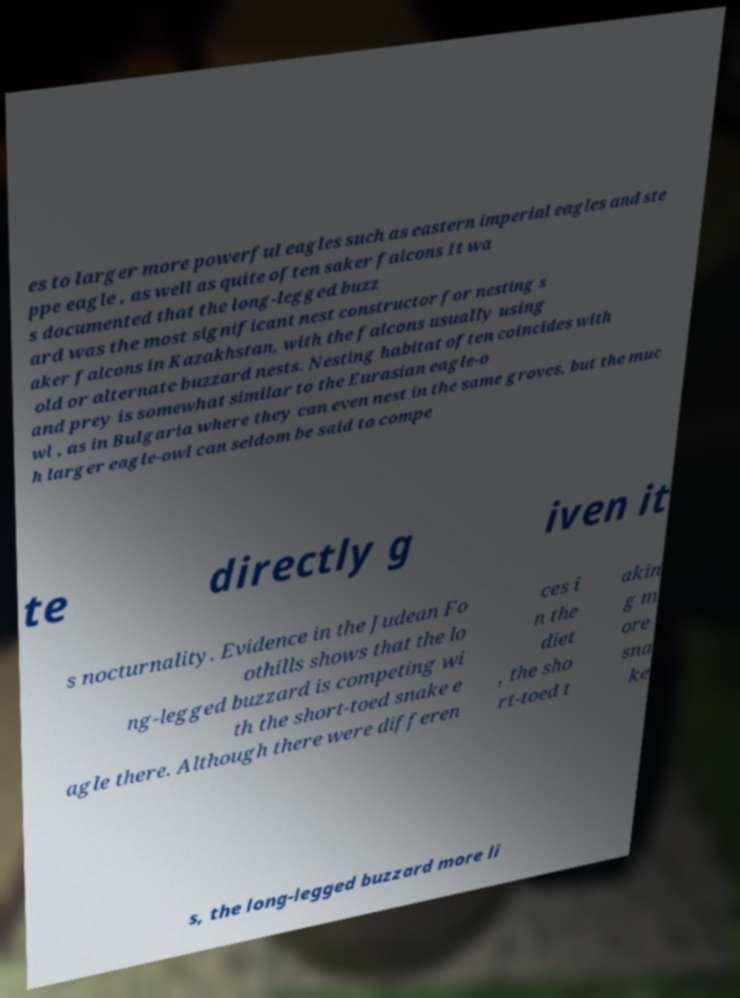There's text embedded in this image that I need extracted. Can you transcribe it verbatim? es to larger more powerful eagles such as eastern imperial eagles and ste ppe eagle , as well as quite often saker falcons It wa s documented that the long-legged buzz ard was the most significant nest constructor for nesting s aker falcons in Kazakhstan, with the falcons usually using old or alternate buzzard nests. Nesting habitat often coincides with and prey is somewhat similar to the Eurasian eagle-o wl , as in Bulgaria where they can even nest in the same groves, but the muc h larger eagle-owl can seldom be said to compe te directly g iven it s nocturnality. Evidence in the Judean Fo othills shows that the lo ng-legged buzzard is competing wi th the short-toed snake e agle there. Although there were differen ces i n the diet , the sho rt-toed t akin g m ore sna ke s, the long-legged buzzard more li 